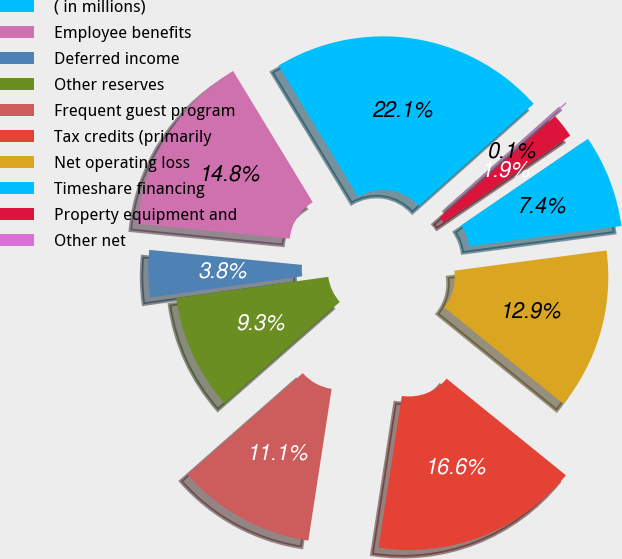Convert chart. <chart><loc_0><loc_0><loc_500><loc_500><pie_chart><fcel>( in millions)<fcel>Employee benefits<fcel>Deferred income<fcel>Other reserves<fcel>Frequent guest program<fcel>Tax credits (primarily<fcel>Net operating loss<fcel>Timeshare financing<fcel>Property equipment and<fcel>Other net<nl><fcel>22.09%<fcel>14.76%<fcel>3.77%<fcel>9.27%<fcel>11.1%<fcel>16.59%<fcel>12.93%<fcel>7.44%<fcel>1.94%<fcel>0.11%<nl></chart> 